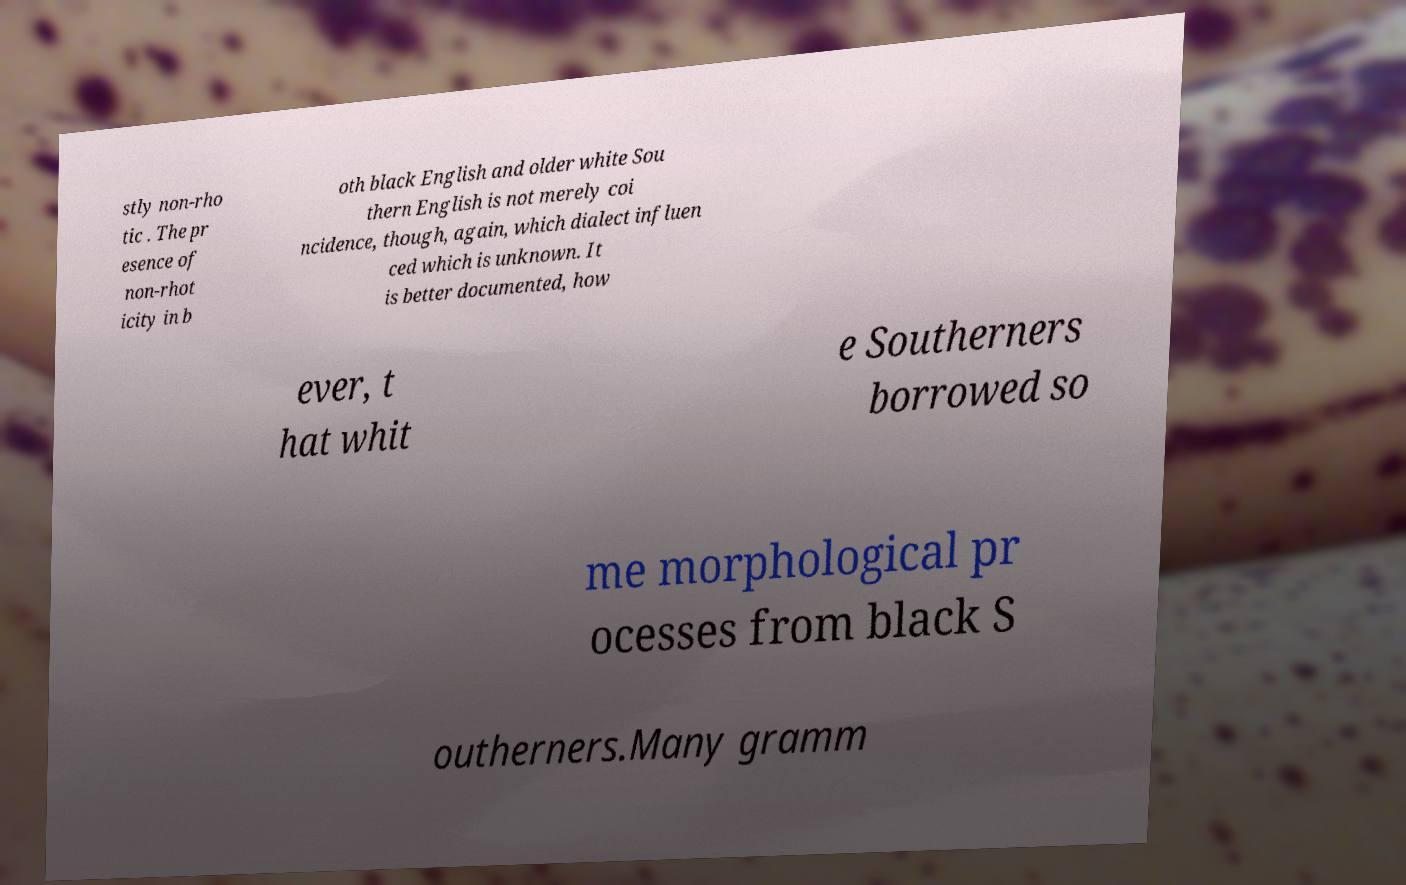Please read and relay the text visible in this image. What does it say? stly non-rho tic . The pr esence of non-rhot icity in b oth black English and older white Sou thern English is not merely coi ncidence, though, again, which dialect influen ced which is unknown. It is better documented, how ever, t hat whit e Southerners borrowed so me morphological pr ocesses from black S outherners.Many gramm 